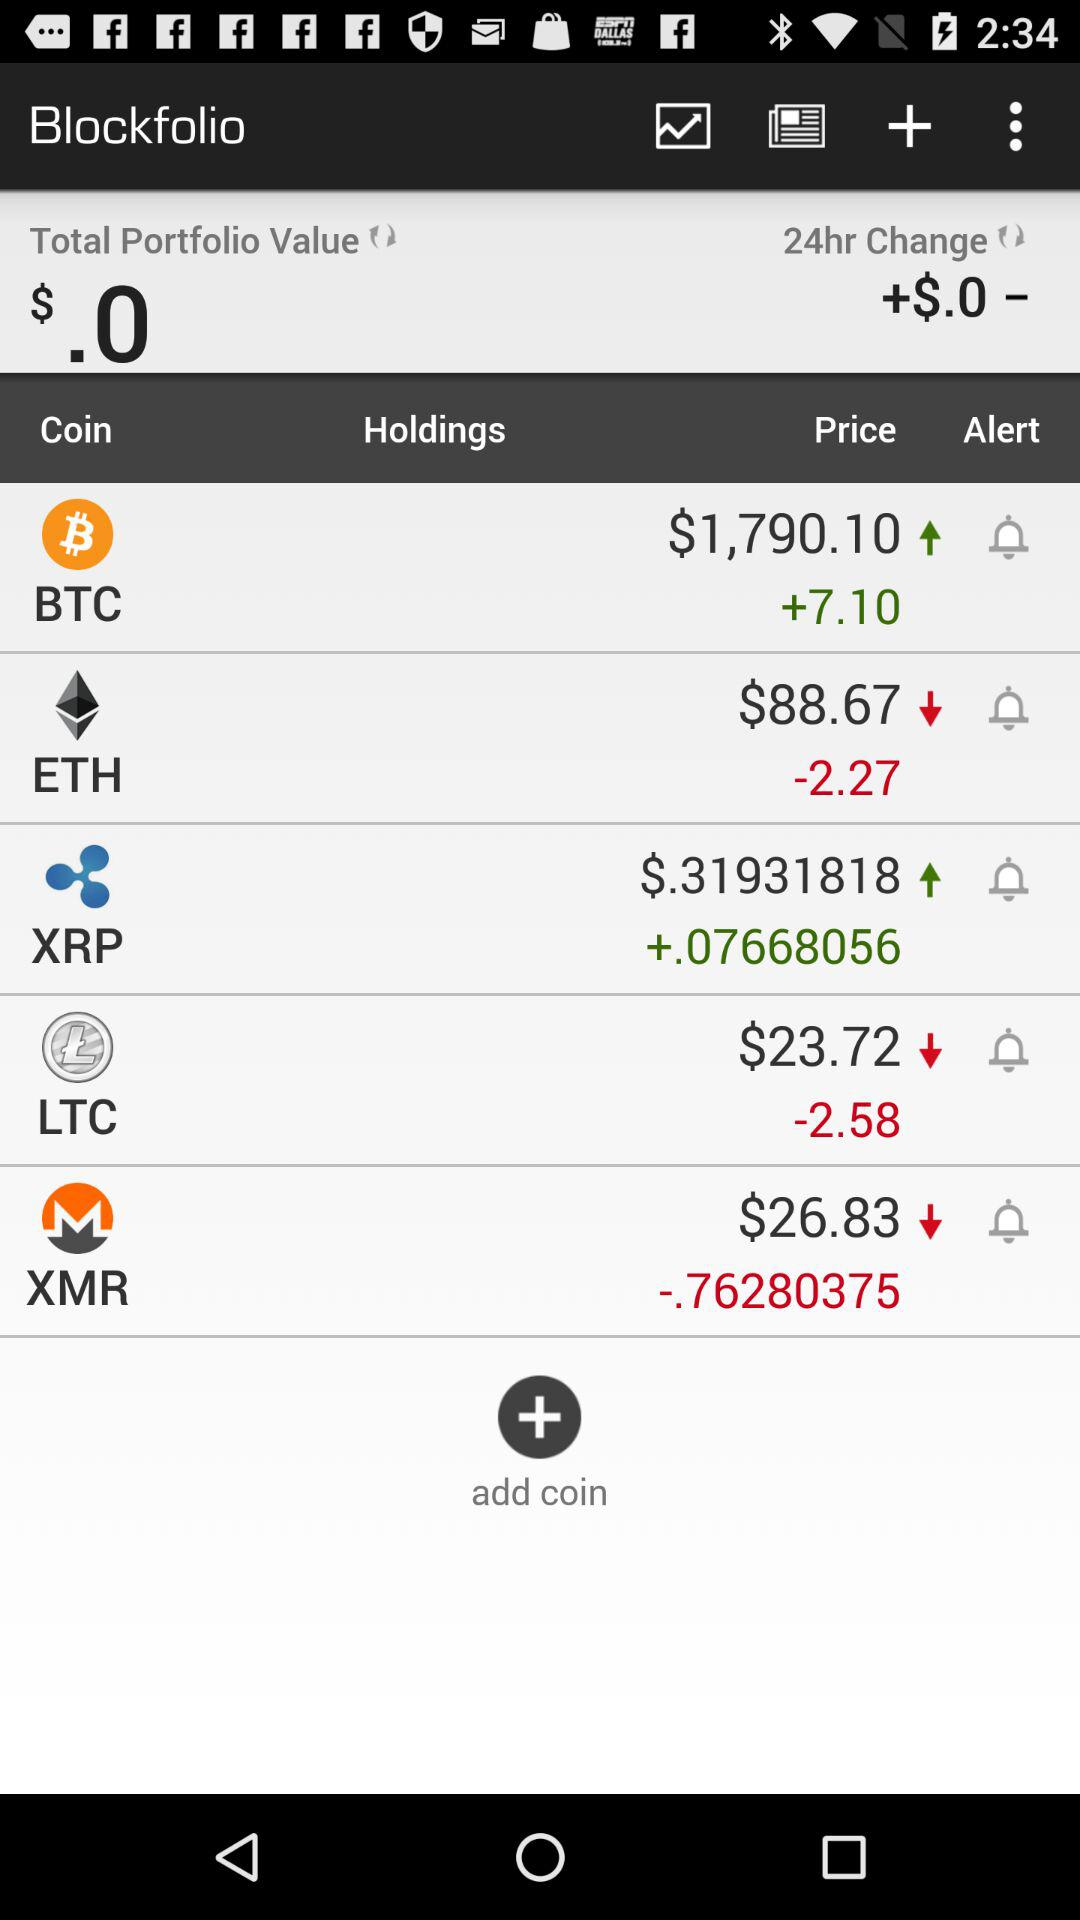What is the price of the XRP coin? The price of the XRP coin is $0.31931818. 